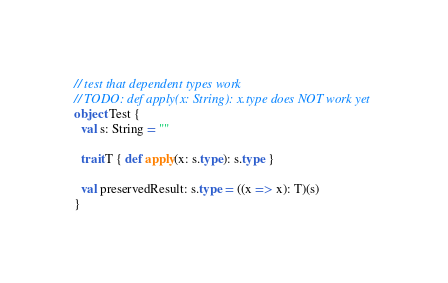<code> <loc_0><loc_0><loc_500><loc_500><_Scala_>// test that dependent types work
// TODO: def apply(x: String): x.type does NOT work yet
object Test {
  val s: String = ""

  trait T { def apply(x: s.type): s.type }

  val preservedResult: s.type = ((x => x): T)(s)
}</code> 